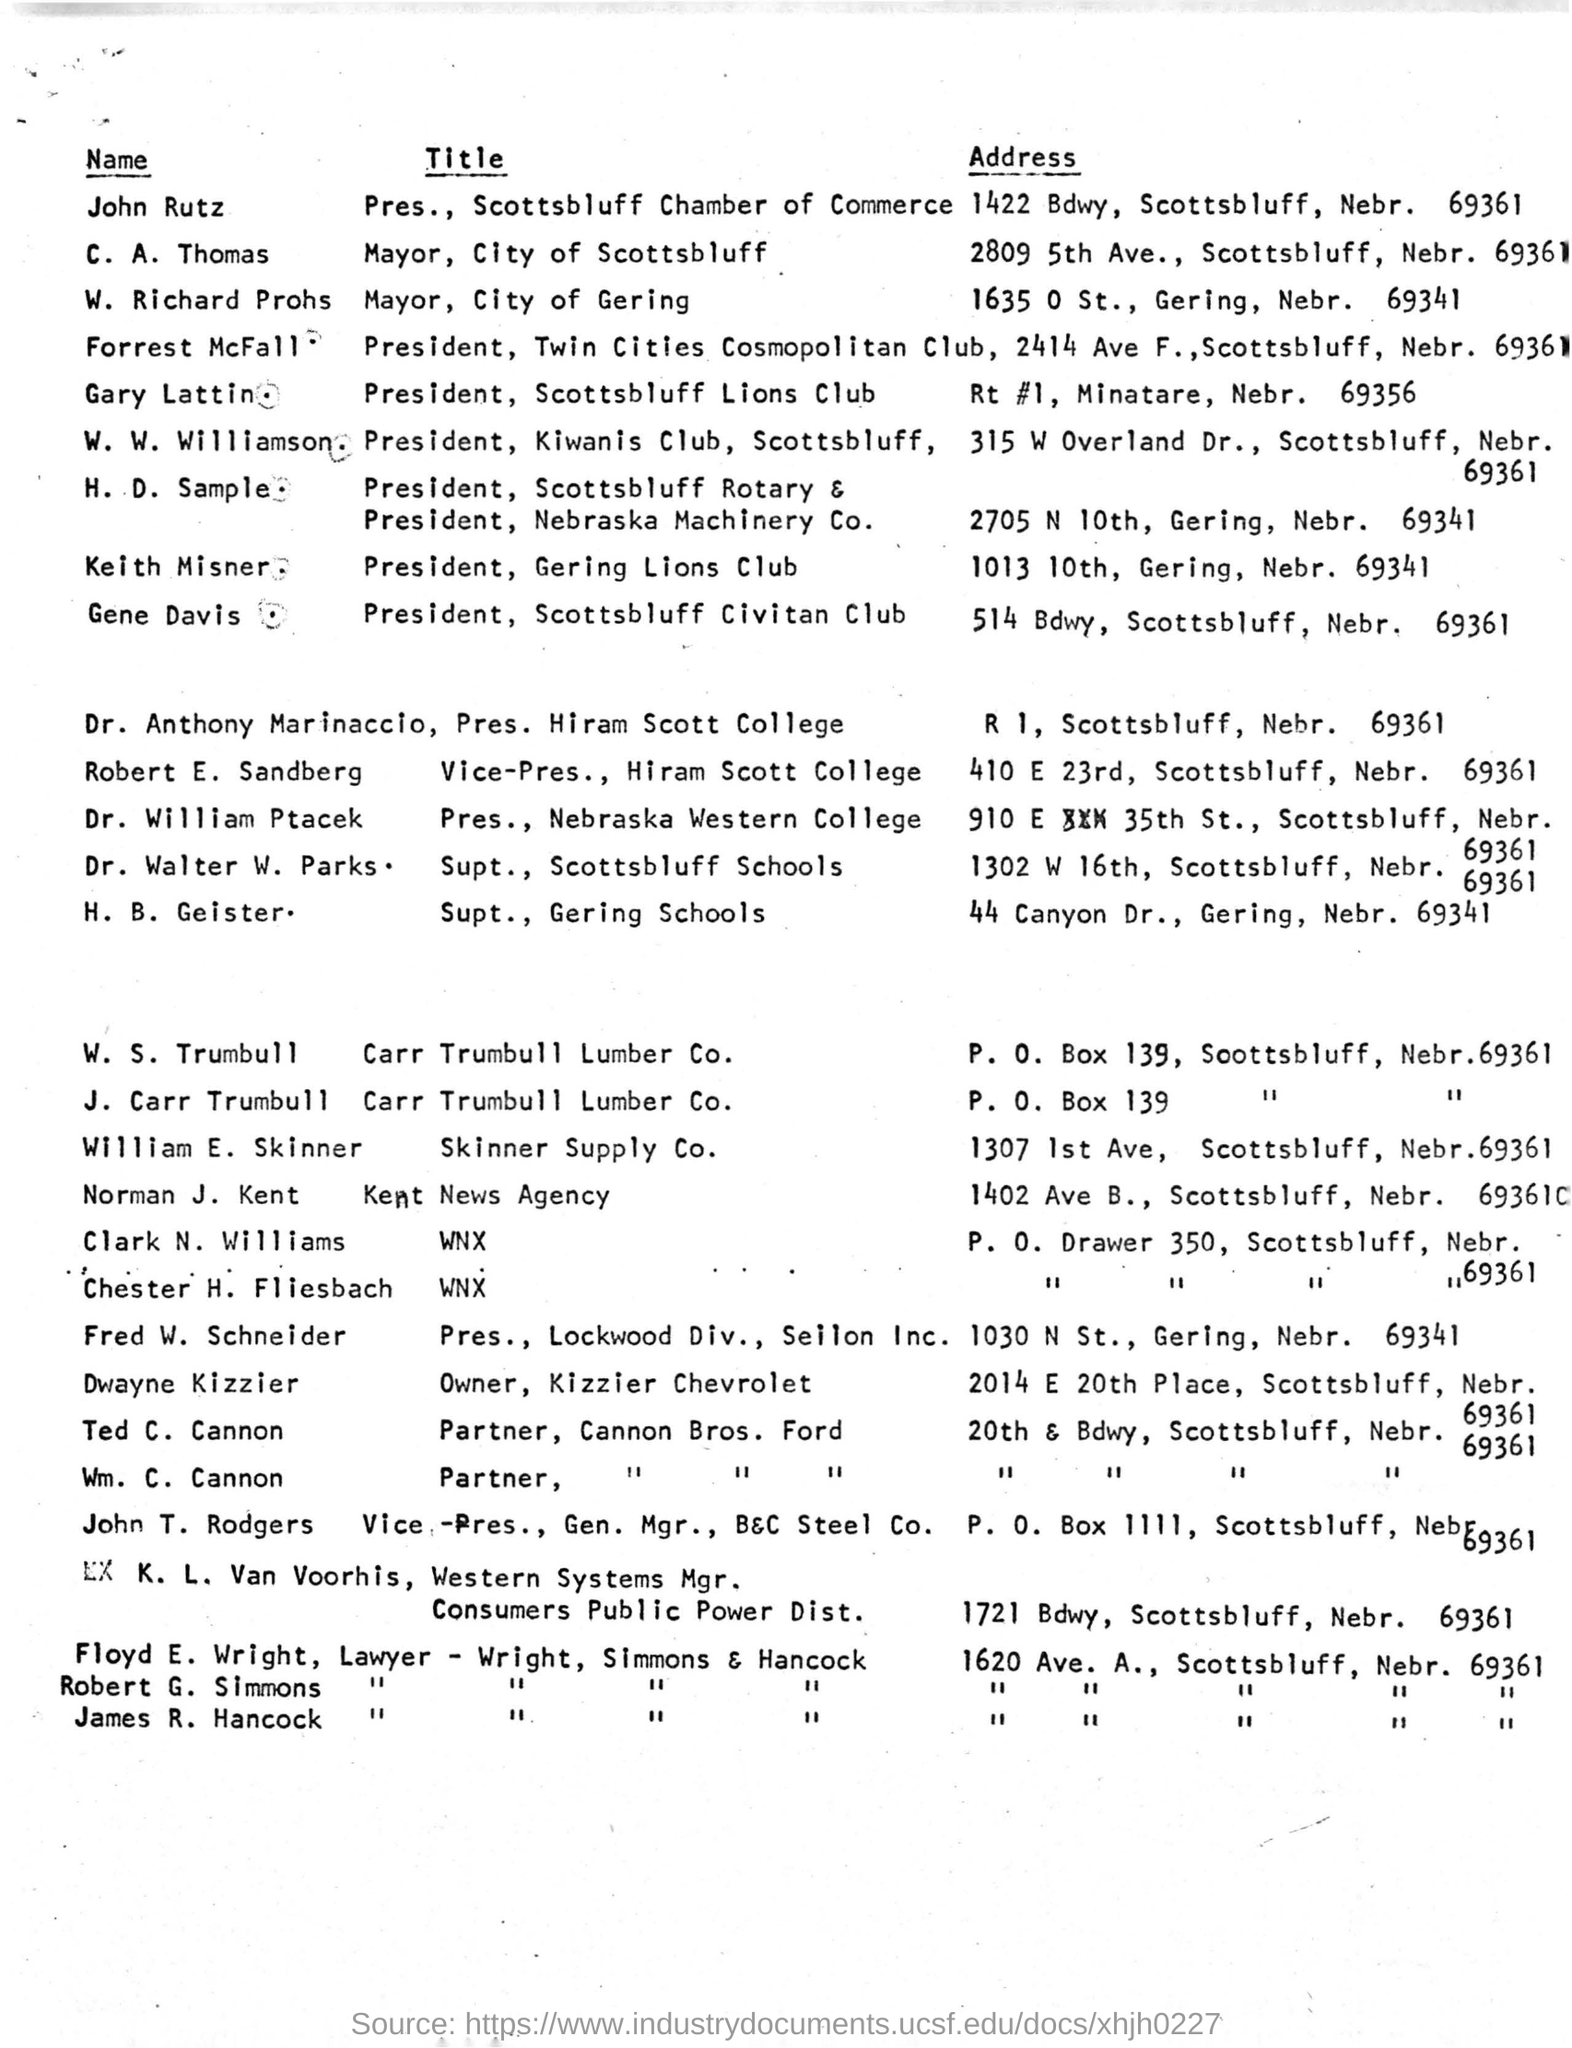Who is the mayor of city of scottsbluff?
Provide a succinct answer. C. A. THOMAS. What is the title of forrest mcfall?
Your response must be concise. President. What is the address of h. b. geister?
Provide a short and direct response. 44 CANYON DR., GERING, NEBR. 69341. 